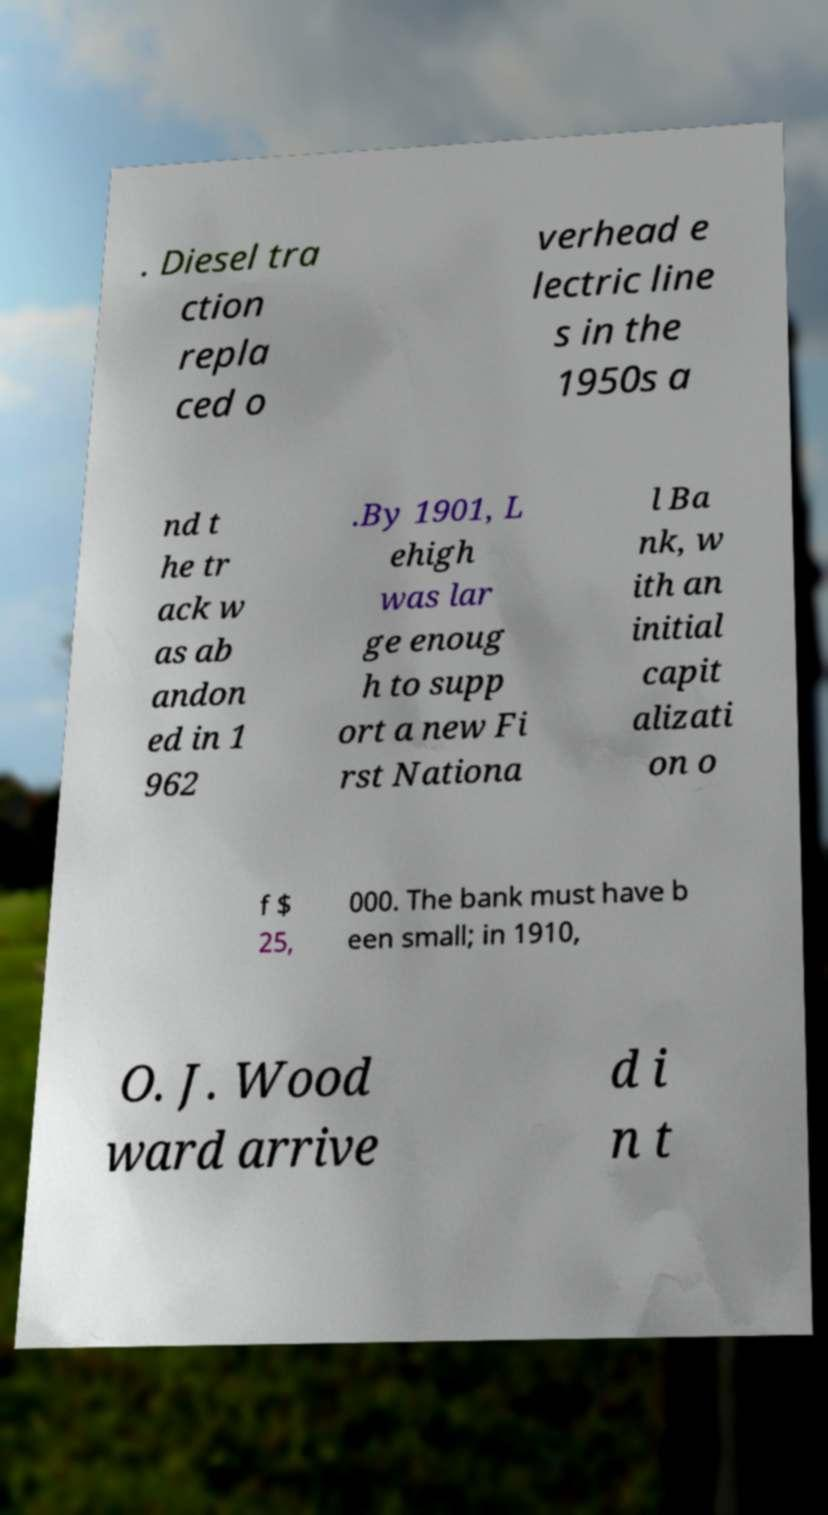For documentation purposes, I need the text within this image transcribed. Could you provide that? . Diesel tra ction repla ced o verhead e lectric line s in the 1950s a nd t he tr ack w as ab andon ed in 1 962 .By 1901, L ehigh was lar ge enoug h to supp ort a new Fi rst Nationa l Ba nk, w ith an initial capit alizati on o f $ 25, 000. The bank must have b een small; in 1910, O. J. Wood ward arrive d i n t 